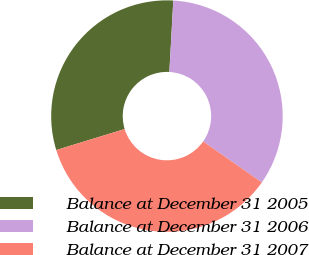<chart> <loc_0><loc_0><loc_500><loc_500><pie_chart><fcel>Balance at December 31 2005<fcel>Balance at December 31 2006<fcel>Balance at December 31 2007<nl><fcel>30.61%<fcel>33.84%<fcel>35.55%<nl></chart> 